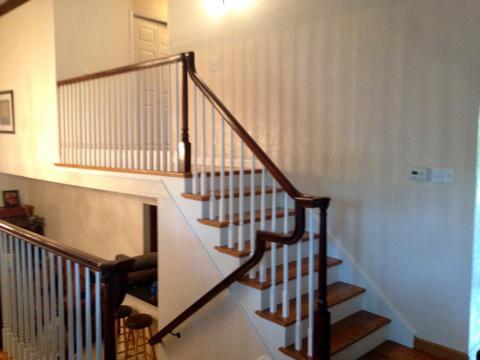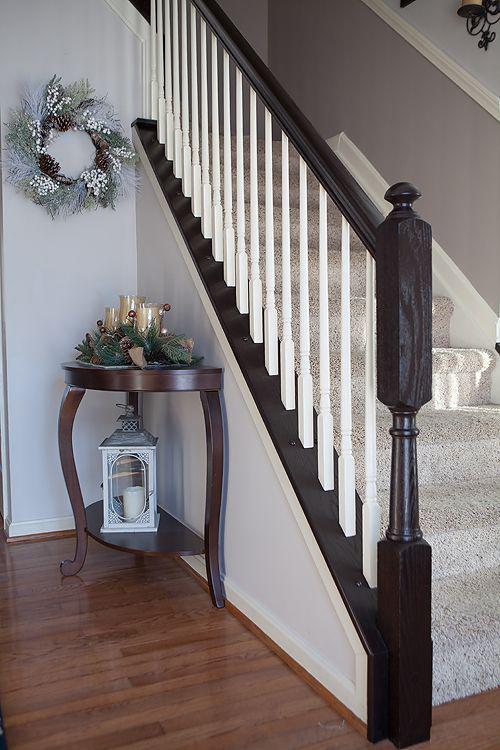The first image is the image on the left, the second image is the image on the right. Examine the images to the left and right. Is the description "Part of the stairway railing is made of glass." accurate? Answer yes or no. No. 